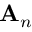<formula> <loc_0><loc_0><loc_500><loc_500>A _ { n }</formula> 